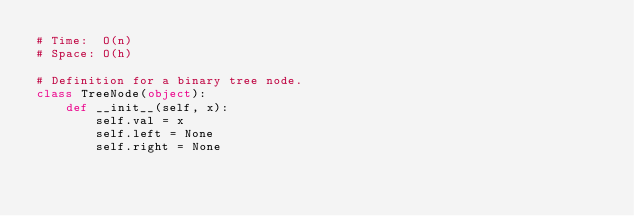<code> <loc_0><loc_0><loc_500><loc_500><_Python_># Time:  O(n)
# Space: O(h)

# Definition for a binary tree node.
class TreeNode(object):
    def __init__(self, x):
        self.val = x
        self.left = None
        self.right = None
</code> 